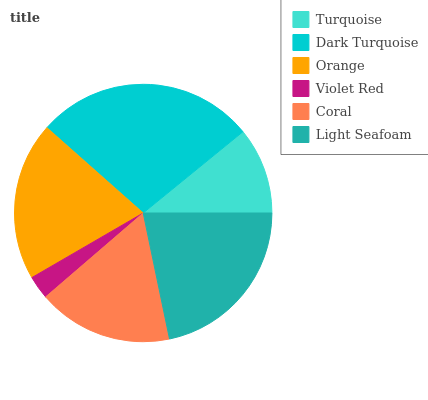Is Violet Red the minimum?
Answer yes or no. Yes. Is Dark Turquoise the maximum?
Answer yes or no. Yes. Is Orange the minimum?
Answer yes or no. No. Is Orange the maximum?
Answer yes or no. No. Is Dark Turquoise greater than Orange?
Answer yes or no. Yes. Is Orange less than Dark Turquoise?
Answer yes or no. Yes. Is Orange greater than Dark Turquoise?
Answer yes or no. No. Is Dark Turquoise less than Orange?
Answer yes or no. No. Is Orange the high median?
Answer yes or no. Yes. Is Coral the low median?
Answer yes or no. Yes. Is Violet Red the high median?
Answer yes or no. No. Is Dark Turquoise the low median?
Answer yes or no. No. 